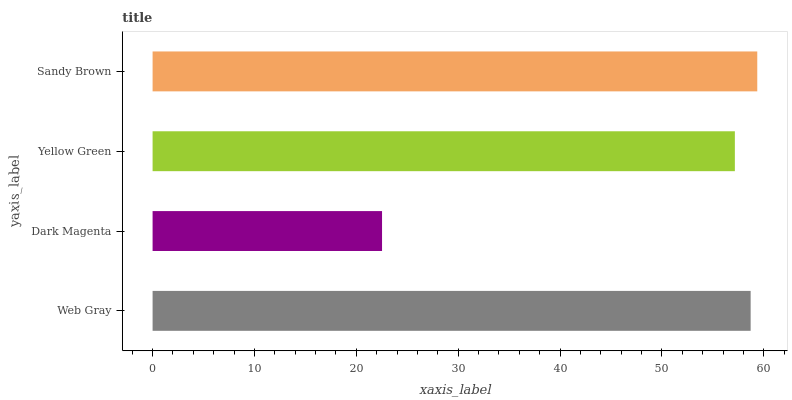Is Dark Magenta the minimum?
Answer yes or no. Yes. Is Sandy Brown the maximum?
Answer yes or no. Yes. Is Yellow Green the minimum?
Answer yes or no. No. Is Yellow Green the maximum?
Answer yes or no. No. Is Yellow Green greater than Dark Magenta?
Answer yes or no. Yes. Is Dark Magenta less than Yellow Green?
Answer yes or no. Yes. Is Dark Magenta greater than Yellow Green?
Answer yes or no. No. Is Yellow Green less than Dark Magenta?
Answer yes or no. No. Is Web Gray the high median?
Answer yes or no. Yes. Is Yellow Green the low median?
Answer yes or no. Yes. Is Yellow Green the high median?
Answer yes or no. No. Is Sandy Brown the low median?
Answer yes or no. No. 